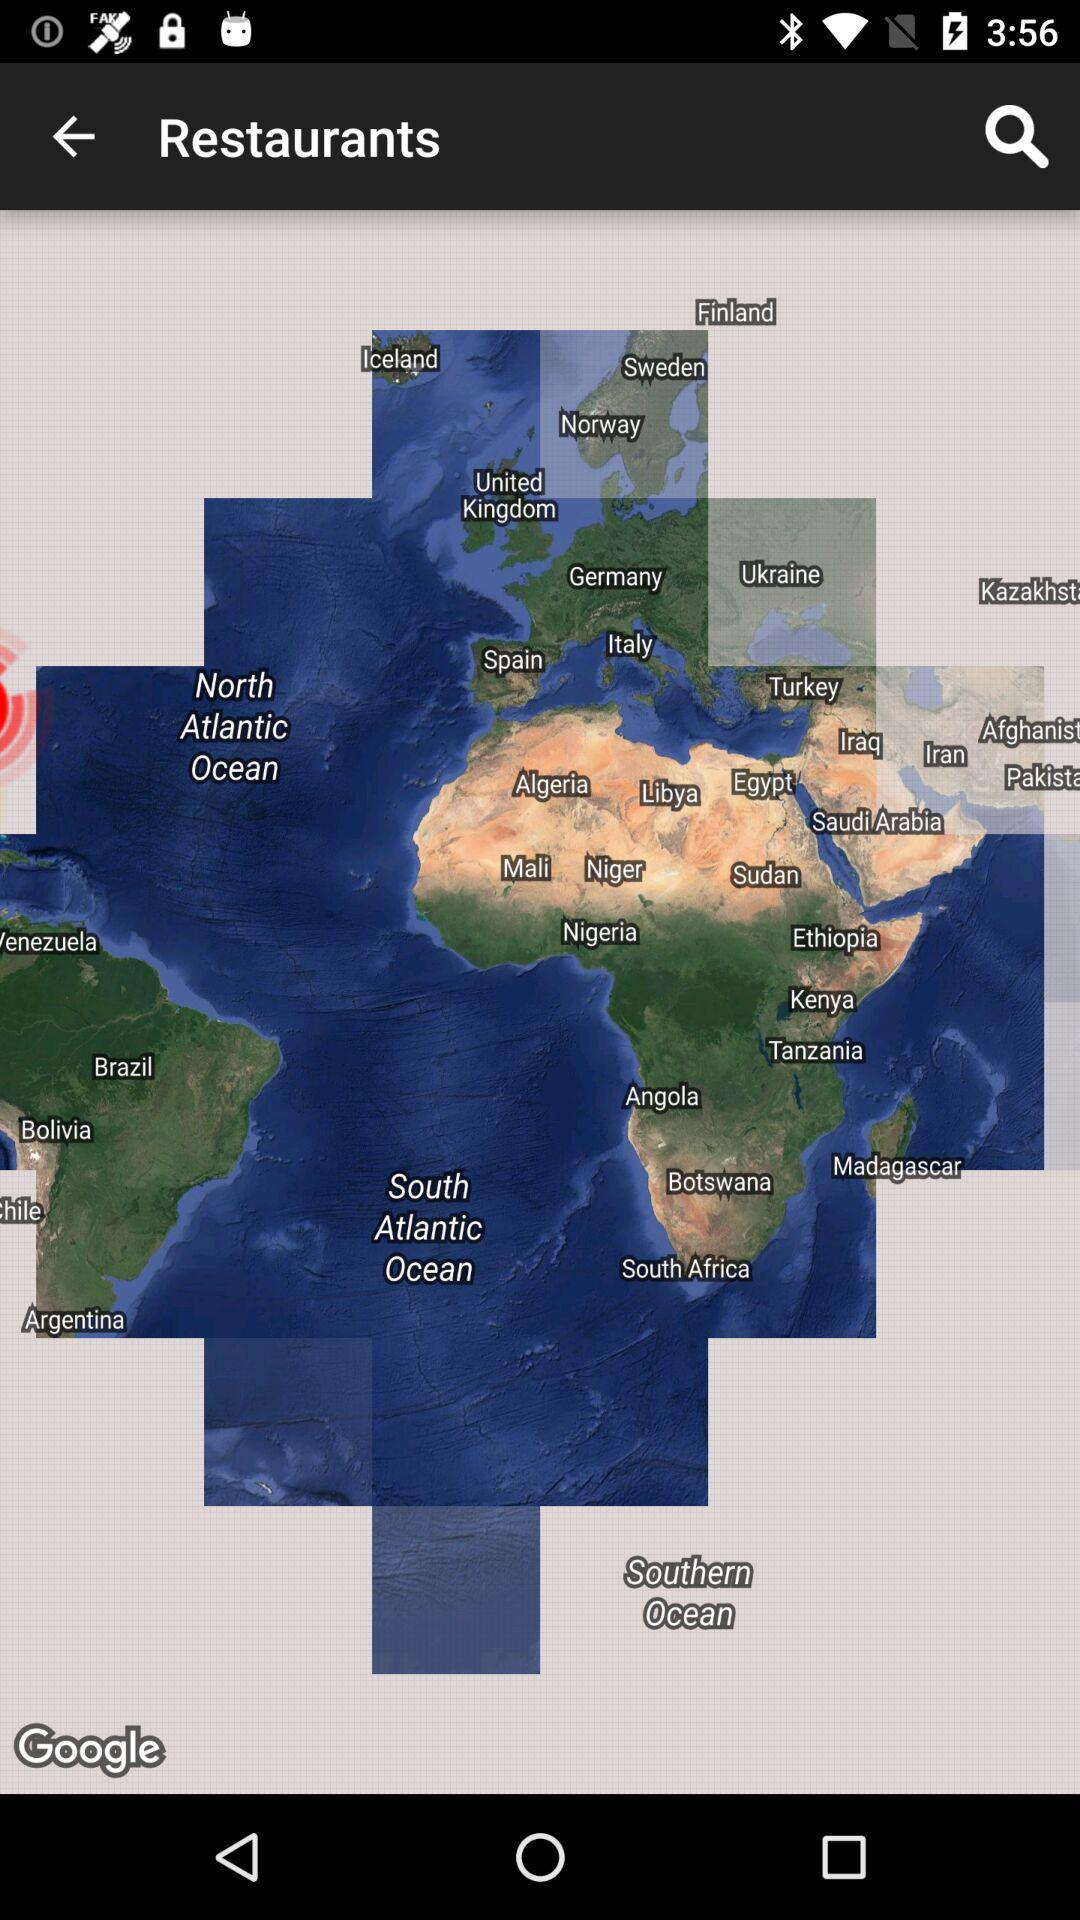What are the ways through which a location can be found? A location can be found through latitude and longitude. 